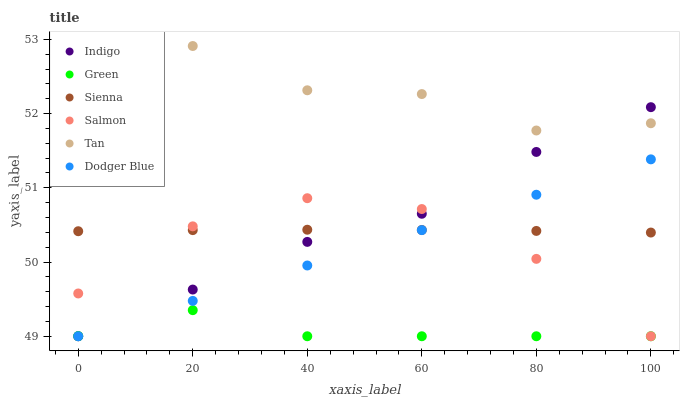Does Green have the minimum area under the curve?
Answer yes or no. Yes. Does Tan have the maximum area under the curve?
Answer yes or no. Yes. Does Salmon have the minimum area under the curve?
Answer yes or no. No. Does Salmon have the maximum area under the curve?
Answer yes or no. No. Is Dodger Blue the smoothest?
Answer yes or no. Yes. Is Tan the roughest?
Answer yes or no. Yes. Is Salmon the smoothest?
Answer yes or no. No. Is Salmon the roughest?
Answer yes or no. No. Does Indigo have the lowest value?
Answer yes or no. Yes. Does Sienna have the lowest value?
Answer yes or no. No. Does Tan have the highest value?
Answer yes or no. Yes. Does Salmon have the highest value?
Answer yes or no. No. Is Dodger Blue less than Tan?
Answer yes or no. Yes. Is Tan greater than Dodger Blue?
Answer yes or no. Yes. Does Indigo intersect Tan?
Answer yes or no. Yes. Is Indigo less than Tan?
Answer yes or no. No. Is Indigo greater than Tan?
Answer yes or no. No. Does Dodger Blue intersect Tan?
Answer yes or no. No. 